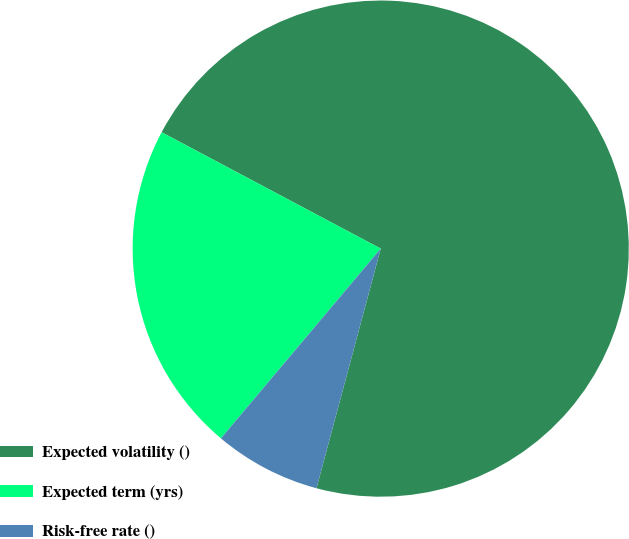<chart> <loc_0><loc_0><loc_500><loc_500><pie_chart><fcel>Expected volatility ()<fcel>Expected term (yrs)<fcel>Risk-free rate ()<nl><fcel>71.39%<fcel>21.63%<fcel>6.97%<nl></chart> 